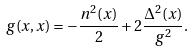Convert formula to latex. <formula><loc_0><loc_0><loc_500><loc_500>g ( x , x ) = - \frac { n ^ { 2 } ( x ) } { 2 } + 2 \frac { \Delta ^ { 2 } ( x ) } { g ^ { 2 } } .</formula> 